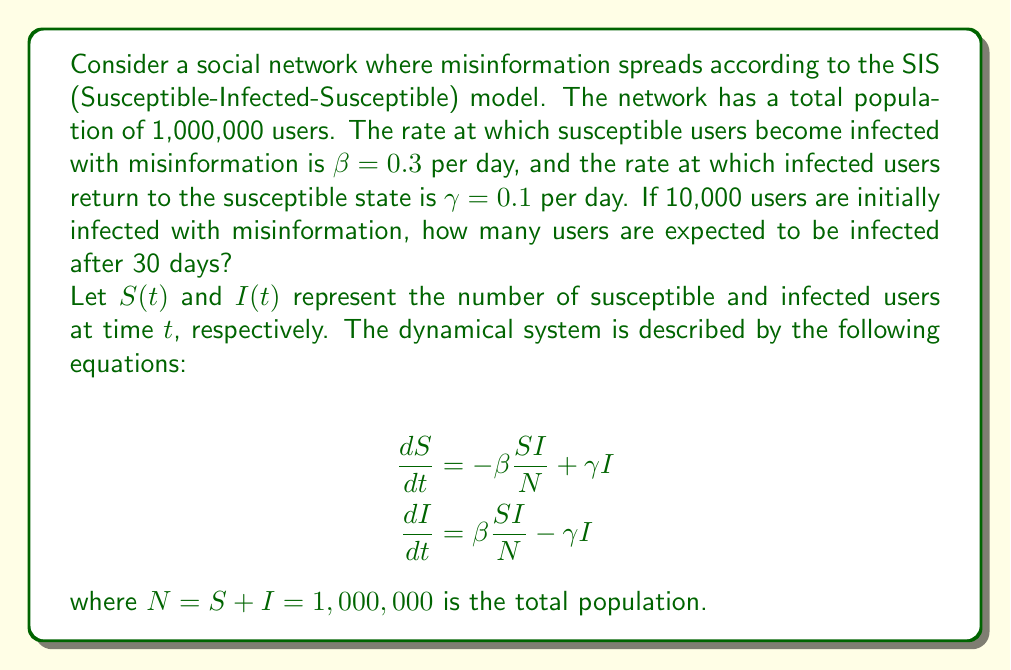Solve this math problem. To solve this problem, we'll follow these steps:

1) First, we need to find the equilibrium point of the system. At equilibrium:

   $$\frac{dI}{dt} = 0 = \beta \frac{SI}{N} - \gamma I$$

   Solving for $S$, we get:

   $$S = \frac{N\gamma}{\beta} = \frac{1,000,000 \cdot 0.1}{0.3} = 333,333$$

2) The number of infected at equilibrium is thus:

   $$I^* = N - S = 1,000,000 - 333,333 = 666,667$$

3) Now, we need to solve the differential equation for $I(t)$. The solution has the form:

   $$I(t) = I^* + (I_0 - I^*) e^{-(\beta - \gamma)t}$$

   where $I_0$ is the initial number of infected users.

4) Substituting our values:

   $$I(t) = 666,667 + (10,000 - 666,667) e^{-(0.3 - 0.1)t}$$
   $$I(t) = 666,667 - 656,667 e^{-0.2t}$$

5) To find the number of infected users after 30 days, we calculate $I(30)$:

   $$I(30) = 666,667 - 656,667 e^{-0.2 \cdot 30}$$
   $$I(30) = 666,667 - 656,667 \cdot (2.06115362 \times 10^{-3})$$
   $$I(30) = 666,667 - 1,353$$
   $$I(30) = 665,314$$

Therefore, after 30 days, approximately 665,314 users are expected to be infected with misinformation.
Answer: 665,314 users 